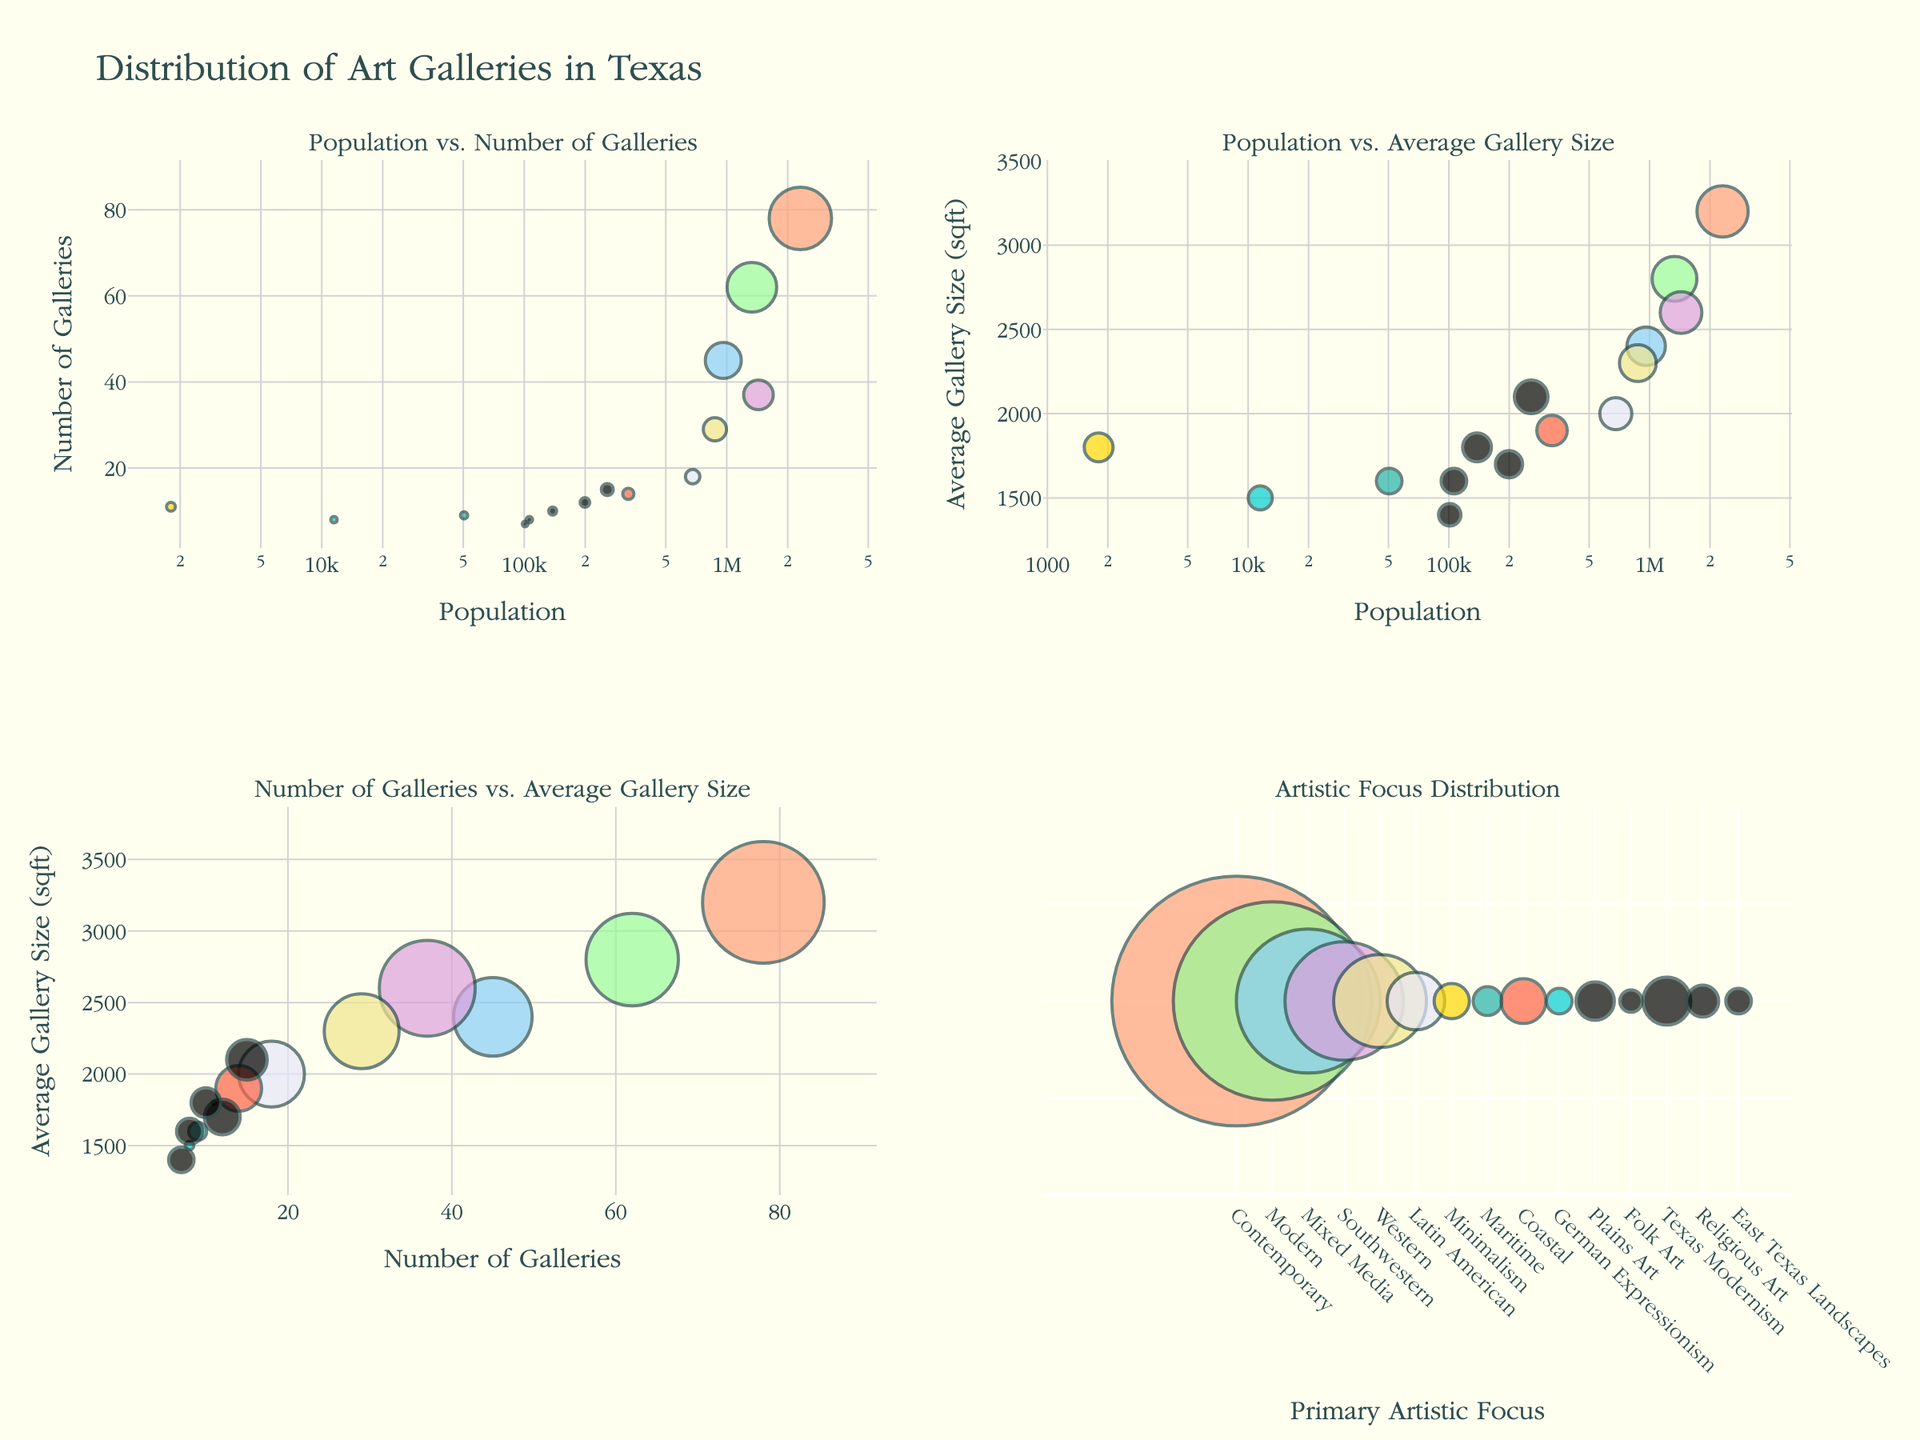Which town had the highest population in 1750? To find the town with the highest population in 1750, look at the population values for each town in 1750. Salem had a population of 3500.
Answer: Salem How many churches did Plymouth have in 1700? Examine the scatterplot for Plymouth for the year 1700 and locate the data point representing the number of churches. Plymouth had 2 churches in 1700.
Answer: 2 What is the trend in militia members for Northampton from 1675 to 1750? Observe the data points for Northampton across the years from 1675 to 1750 in the militia members plot. The number of militia members increased from 50 in 1675 to 180 in 1750, showing an increasing trend.
Answer: Increasing Compare the population growth rate of Salem and Plymouth from 1650 to 1750. Which town had a higher growth rate? Calculate the growth rate for each town from 1650 to 1750 by subtracting the population in 1650 from the population in 1750. Salem's growth rate: 3500 - 900 = 2600, Plymouth's growth rate: 2800 - 750 = 2050. Salem had a higher growth rate.
Answer: Salem How many towns had more than 500 militia members in total by 1750? Add the number of militia members for each town in 1750. Salem: 280, Plymouth: 220, Deerfield: 90, Northampton: 180, Windsor: 160. Sum of each town’s militia members exceeds 500.
Answer: 5 Which town had the smallest acreage throughout the recorded years? Compare the acreage data points for all towns over the years. Deerfield had the smallest acreage at 1500 in 1700.
Answer: Deerfield What is the average increase in population for Windsor between each recorded year? Windsor's population increased from 450 in 1650 to 1000 in 1700 and to 1900 in 1750. Calculate the average increase: (1000 - 450) + (1900 - 1000) = 550 + 900 = 1450. Average increase = 1450 / 2 = 725.
Answer: 725 Compare the number of churches between Deerfield and Windsor in 1700. Which town had more churches? Examine the churches data points for both towns in 1700. Both Deerfield and Windsor had 1 church each.
Answer: Same What's the ratio of population to acreage for Deerfield in 1750? Deerfield's population in 1750 was 850, and acreage was 4200. Calculate the ratio: 850 / 4200 = 0.202.
Answer: 0.202 